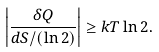Convert formula to latex. <formula><loc_0><loc_0><loc_500><loc_500>\left | \frac { \delta Q } { d S / ( \ln 2 ) } \right | \geq k T \ln 2 .</formula> 